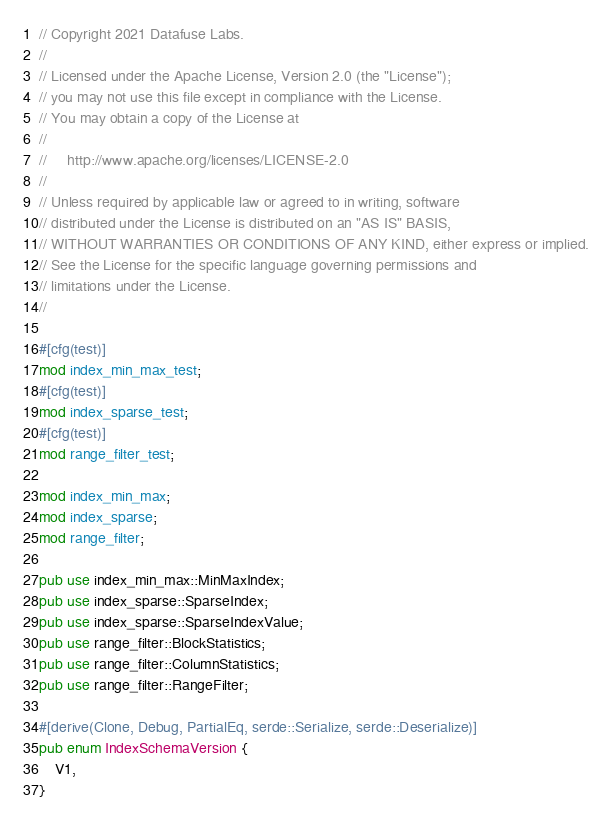Convert code to text. <code><loc_0><loc_0><loc_500><loc_500><_Rust_>// Copyright 2021 Datafuse Labs.
//
// Licensed under the Apache License, Version 2.0 (the "License");
// you may not use this file except in compliance with the License.
// You may obtain a copy of the License at
//
//     http://www.apache.org/licenses/LICENSE-2.0
//
// Unless required by applicable law or agreed to in writing, software
// distributed under the License is distributed on an "AS IS" BASIS,
// WITHOUT WARRANTIES OR CONDITIONS OF ANY KIND, either express or implied.
// See the License for the specific language governing permissions and
// limitations under the License.
//

#[cfg(test)]
mod index_min_max_test;
#[cfg(test)]
mod index_sparse_test;
#[cfg(test)]
mod range_filter_test;

mod index_min_max;
mod index_sparse;
mod range_filter;

pub use index_min_max::MinMaxIndex;
pub use index_sparse::SparseIndex;
pub use index_sparse::SparseIndexValue;
pub use range_filter::BlockStatistics;
pub use range_filter::ColumnStatistics;
pub use range_filter::RangeFilter;

#[derive(Clone, Debug, PartialEq, serde::Serialize, serde::Deserialize)]
pub enum IndexSchemaVersion {
    V1,
}
</code> 